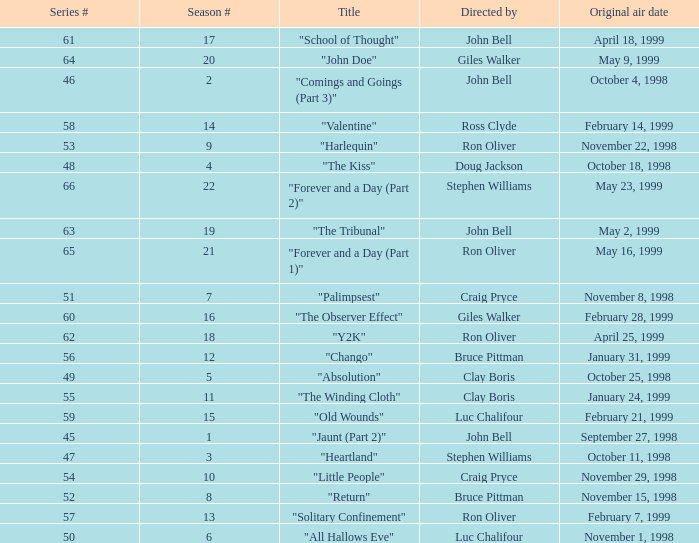Which Season # has a Title of "jaunt (part 2)", and a Series # larger than 45? None. 